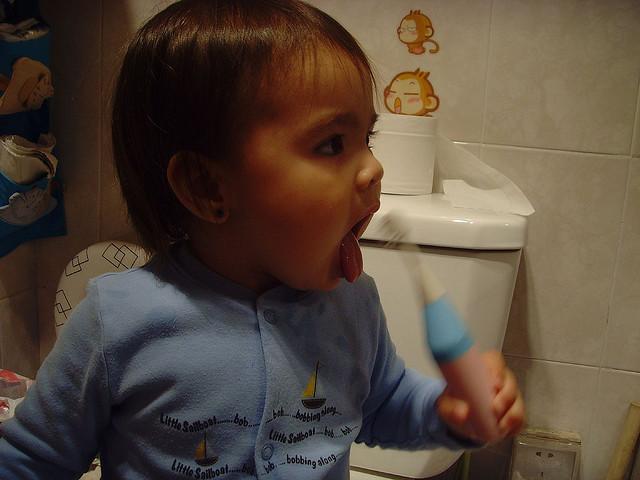What is she trying to catch in her mouth?
Be succinct. Toothbrush. What machine is this child using?
Keep it brief. Toothbrush. How many snaps are on the child's shirt?
Quick response, please. 2. Is the person facing the camera?
Short answer required. No. What is in the baby's mouth?
Short answer required. Toothbrush. What is the baby doing?
Answer briefly. Brushing teeth. Is this a light up toy?
Answer briefly. No. What is the boy holding?
Answer briefly. Toothbrush. What is on the back of the toilet tank?
Be succinct. Toilet paper. What is the child holding in her left hand?
Concise answer only. Toothbrush. Does this child like the toilet?
Quick response, please. No. Is the baby a boy or girl?
Keep it brief. Girl. Is there a plant in the picture?
Write a very short answer. No. 